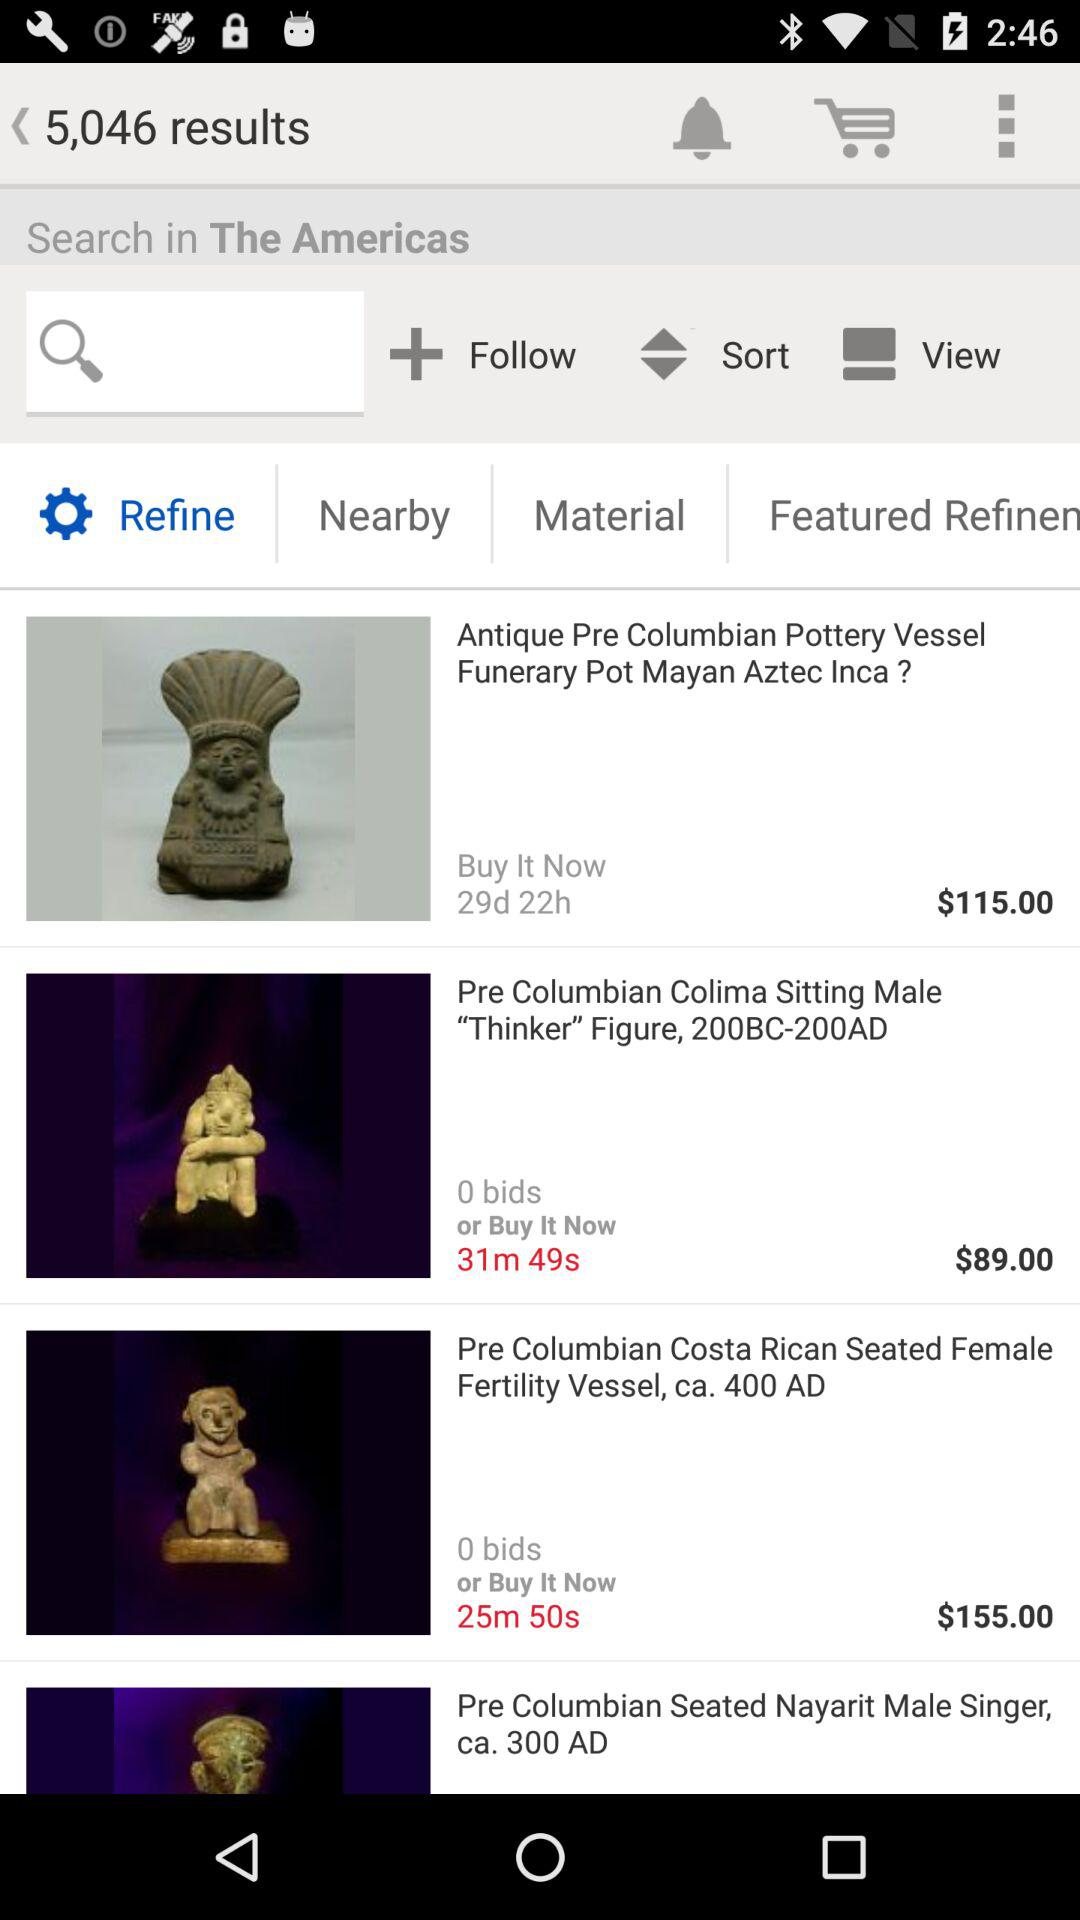How many results are shown in total? The results that are shown in total are 5,046. 